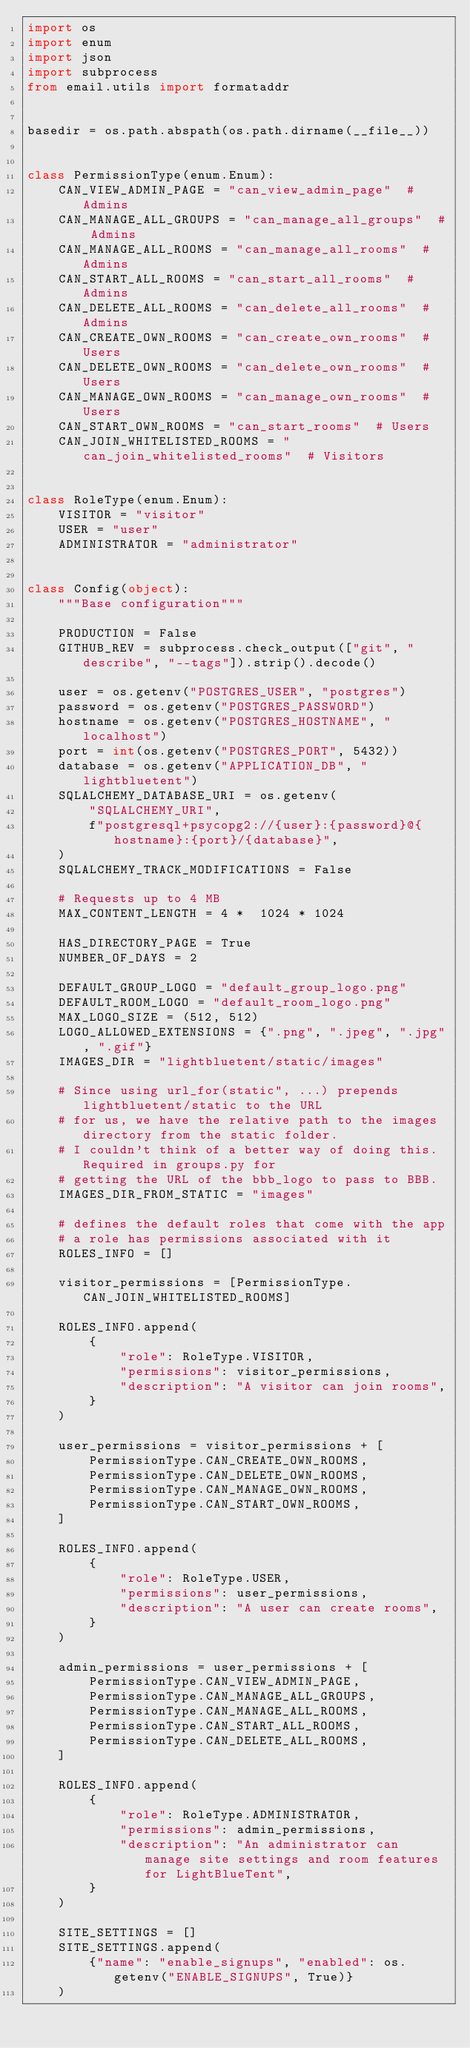<code> <loc_0><loc_0><loc_500><loc_500><_Python_>import os
import enum
import json
import subprocess
from email.utils import formataddr


basedir = os.path.abspath(os.path.dirname(__file__))


class PermissionType(enum.Enum):
    CAN_VIEW_ADMIN_PAGE = "can_view_admin_page"  # Admins
    CAN_MANAGE_ALL_GROUPS = "can_manage_all_groups"  # Admins
    CAN_MANAGE_ALL_ROOMS = "can_manage_all_rooms"  # Admins
    CAN_START_ALL_ROOMS = "can_start_all_rooms"  # Admins
    CAN_DELETE_ALL_ROOMS = "can_delete_all_rooms"  # Admins
    CAN_CREATE_OWN_ROOMS = "can_create_own_rooms"  # Users
    CAN_DELETE_OWN_ROOMS = "can_delete_own_rooms"  # Users
    CAN_MANAGE_OWN_ROOMS = "can_manage_own_rooms"  # Users
    CAN_START_OWN_ROOMS = "can_start_rooms"  # Users
    CAN_JOIN_WHITELISTED_ROOMS = "can_join_whitelisted_rooms"  # Visitors


class RoleType(enum.Enum):
    VISITOR = "visitor"
    USER = "user"
    ADMINISTRATOR = "administrator"


class Config(object):
    """Base configuration"""

    PRODUCTION = False
    GITHUB_REV = subprocess.check_output(["git", "describe", "--tags"]).strip().decode()

    user = os.getenv("POSTGRES_USER", "postgres")
    password = os.getenv("POSTGRES_PASSWORD")
    hostname = os.getenv("POSTGRES_HOSTNAME", "localhost")
    port = int(os.getenv("POSTGRES_PORT", 5432))
    database = os.getenv("APPLICATION_DB", "lightbluetent")
    SQLALCHEMY_DATABASE_URI = os.getenv(
        "SQLALCHEMY_URI",
        f"postgresql+psycopg2://{user}:{password}@{hostname}:{port}/{database}",
    )
    SQLALCHEMY_TRACK_MODIFICATIONS = False

    # Requests up to 4 MB
    MAX_CONTENT_LENGTH = 4 *  1024 * 1024

    HAS_DIRECTORY_PAGE = True
    NUMBER_OF_DAYS = 2

    DEFAULT_GROUP_LOGO = "default_group_logo.png"
    DEFAULT_ROOM_LOGO = "default_room_logo.png"
    MAX_LOGO_SIZE = (512, 512)
    LOGO_ALLOWED_EXTENSIONS = {".png", ".jpeg", ".jpg", ".gif"}
    IMAGES_DIR = "lightbluetent/static/images"

    # Since using url_for(static", ...) prepends lightbluetent/static to the URL
    # for us, we have the relative path to the images directory from the static folder.
    # I couldn't think of a better way of doing this. Required in groups.py for
    # getting the URL of the bbb_logo to pass to BBB.
    IMAGES_DIR_FROM_STATIC = "images"

    # defines the default roles that come with the app
    # a role has permissions associated with it
    ROLES_INFO = []

    visitor_permissions = [PermissionType.CAN_JOIN_WHITELISTED_ROOMS]

    ROLES_INFO.append(
        {
            "role": RoleType.VISITOR,
            "permissions": visitor_permissions,
            "description": "A visitor can join rooms",
        }
    )

    user_permissions = visitor_permissions + [
        PermissionType.CAN_CREATE_OWN_ROOMS,
        PermissionType.CAN_DELETE_OWN_ROOMS,
        PermissionType.CAN_MANAGE_OWN_ROOMS,
        PermissionType.CAN_START_OWN_ROOMS,
    ]

    ROLES_INFO.append(
        {
            "role": RoleType.USER,
            "permissions": user_permissions,
            "description": "A user can create rooms",
        }
    )

    admin_permissions = user_permissions + [
        PermissionType.CAN_VIEW_ADMIN_PAGE,
        PermissionType.CAN_MANAGE_ALL_GROUPS,
        PermissionType.CAN_MANAGE_ALL_ROOMS,
        PermissionType.CAN_START_ALL_ROOMS,
        PermissionType.CAN_DELETE_ALL_ROOMS,
    ]

    ROLES_INFO.append(
        {
            "role": RoleType.ADMINISTRATOR,
            "permissions": admin_permissions,
            "description": "An administrator can manage site settings and room features for LightBlueTent",
        }
    )

    SITE_SETTINGS = []
    SITE_SETTINGS.append(
        {"name": "enable_signups", "enabled": os.getenv("ENABLE_SIGNUPS", True)}
    )</code> 